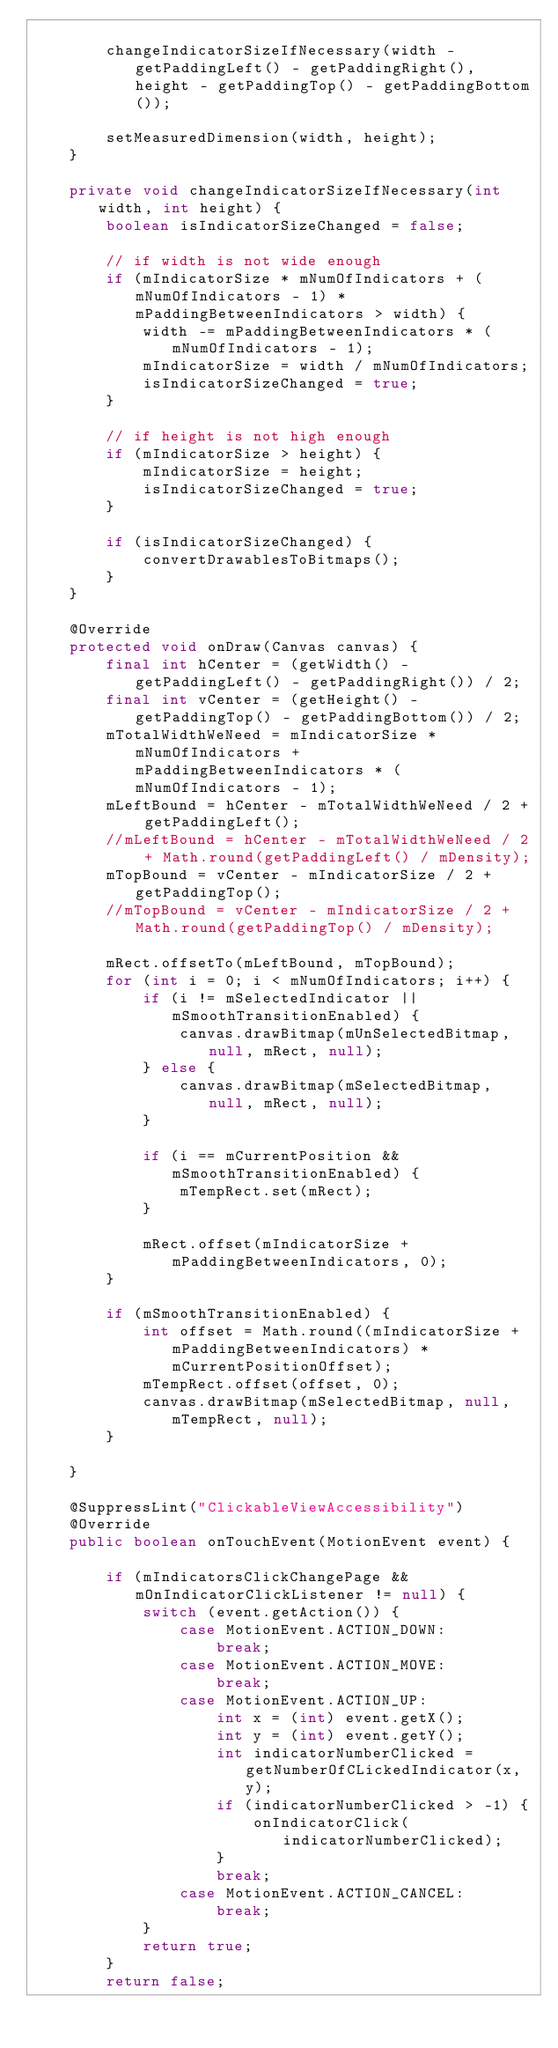Convert code to text. <code><loc_0><loc_0><loc_500><loc_500><_Java_>
        changeIndicatorSizeIfNecessary(width - getPaddingLeft() - getPaddingRight(), height - getPaddingTop() - getPaddingBottom());

        setMeasuredDimension(width, height);
    }

    private void changeIndicatorSizeIfNecessary(int width, int height) {
        boolean isIndicatorSizeChanged = false;

        // if width is not wide enough
        if (mIndicatorSize * mNumOfIndicators + (mNumOfIndicators - 1) * mPaddingBetweenIndicators > width) {
            width -= mPaddingBetweenIndicators * (mNumOfIndicators - 1);
            mIndicatorSize = width / mNumOfIndicators;
            isIndicatorSizeChanged = true;
        }

        // if height is not high enough
        if (mIndicatorSize > height) {
            mIndicatorSize = height;
            isIndicatorSizeChanged = true;
        }

        if (isIndicatorSizeChanged) {
            convertDrawablesToBitmaps();
        }
    }

    @Override
    protected void onDraw(Canvas canvas) {
        final int hCenter = (getWidth() - getPaddingLeft() - getPaddingRight()) / 2;
        final int vCenter = (getHeight() - getPaddingTop() - getPaddingBottom()) / 2;
        mTotalWidthWeNeed = mIndicatorSize * mNumOfIndicators + mPaddingBetweenIndicators * (mNumOfIndicators - 1);
        mLeftBound = hCenter - mTotalWidthWeNeed / 2 + getPaddingLeft();
        //mLeftBound = hCenter - mTotalWidthWeNeed / 2 + Math.round(getPaddingLeft() / mDensity);
        mTopBound = vCenter - mIndicatorSize / 2 + getPaddingTop();
        //mTopBound = vCenter - mIndicatorSize / 2 + Math.round(getPaddingTop() / mDensity);

        mRect.offsetTo(mLeftBound, mTopBound);
        for (int i = 0; i < mNumOfIndicators; i++) {
            if (i != mSelectedIndicator || mSmoothTransitionEnabled) {
                canvas.drawBitmap(mUnSelectedBitmap, null, mRect, null);
            } else {
                canvas.drawBitmap(mSelectedBitmap, null, mRect, null);
            }

            if (i == mCurrentPosition && mSmoothTransitionEnabled) {
                mTempRect.set(mRect);
            }

            mRect.offset(mIndicatorSize + mPaddingBetweenIndicators, 0);
        }

        if (mSmoothTransitionEnabled) {
            int offset = Math.round((mIndicatorSize + mPaddingBetweenIndicators) * mCurrentPositionOffset);
            mTempRect.offset(offset, 0);
            canvas.drawBitmap(mSelectedBitmap, null, mTempRect, null);
        }

    }

    @SuppressLint("ClickableViewAccessibility")
    @Override
    public boolean onTouchEvent(MotionEvent event) {

        if (mIndicatorsClickChangePage && mOnIndicatorClickListener != null) {
            switch (event.getAction()) {
                case MotionEvent.ACTION_DOWN:
                    break;
                case MotionEvent.ACTION_MOVE:
                    break;
                case MotionEvent.ACTION_UP:
                    int x = (int) event.getX();
                    int y = (int) event.getY();
                    int indicatorNumberClicked = getNumberOfCLickedIndicator(x, y);
                    if (indicatorNumberClicked > -1) {
                        onIndicatorClick(indicatorNumberClicked);
                    }
                    break;
                case MotionEvent.ACTION_CANCEL:
                    break;
            }
            return true;
        }
        return false;</code> 